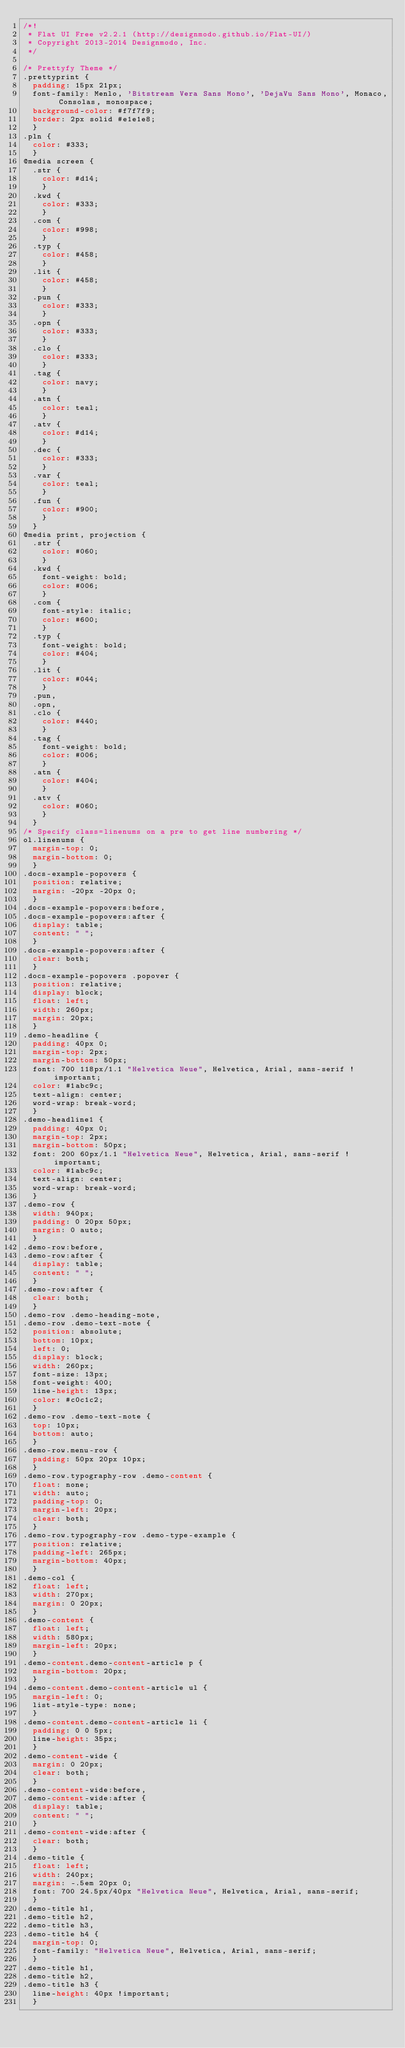Convert code to text. <code><loc_0><loc_0><loc_500><loc_500><_CSS_>/*!
 * Flat UI Free v2.2.1 (http://designmodo.github.io/Flat-UI/)
 * Copyright 2013-2014 Designmodo, Inc.
 */

/* Prettyfy Theme */
.prettyprint {
  padding: 15px 21px;
  font-family: Menlo, 'Bitstream Vera Sans Mono', 'DejaVu Sans Mono', Monaco, Consolas, monospace;
  background-color: #f7f7f9;
  border: 2px solid #e1e1e8;
  }
.pln {
  color: #333;
  }
@media screen {
  .str {
    color: #d14;
    }
  .kwd {
    color: #333;
    }
  .com {
    color: #998;
    }
  .typ {
    color: #458;
    }
  .lit {
    color: #458;
    }
  .pun {
    color: #333;
    }
  .opn {
    color: #333;
    }
  .clo {
    color: #333;
    }
  .tag {
    color: navy;
    }
  .atn {
    color: teal;
    }
  .atv {
    color: #d14;
    }
  .dec {
    color: #333;
    }
  .var {
    color: teal;
    }
  .fun {
    color: #900;
    }
  }
@media print, projection {
  .str {
    color: #060;
    }
  .kwd {
    font-weight: bold;
    color: #006;
    }
  .com {
    font-style: italic;
    color: #600;
    }
  .typ {
    font-weight: bold;
    color: #404;
    }
  .lit {
    color: #044;
    }
  .pun,
  .opn,
  .clo {
    color: #440;
    }
  .tag {
    font-weight: bold;
    color: #006;
    }
  .atn {
    color: #404;
    }
  .atv {
    color: #060;
    }
  }
/* Specify class=linenums on a pre to get line numbering */
ol.linenums {
  margin-top: 0;
  margin-bottom: 0;
  }
.docs-example-popovers {
  position: relative;
  margin: -20px -20px 0;
  }
.docs-example-popovers:before,
.docs-example-popovers:after {
  display: table;
  content: " ";
  }
.docs-example-popovers:after {
  clear: both;
  }
.docs-example-popovers .popover {
  position: relative;
  display: block;
  float: left;
  width: 260px;
  margin: 20px;
  }
.demo-headline {
  padding: 40px 0;
  margin-top: 2px;
  margin-bottom: 50px;
  font: 700 118px/1.1 "Helvetica Neue", Helvetica, Arial, sans-serif !important;
  color: #1abc9c;
  text-align: center;
  word-wrap: break-word;
  }
.demo-headline1 {
  padding: 40px 0;
  margin-top: 2px;
  margin-bottom: 50px;
  font: 200 60px/1.1 "Helvetica Neue", Helvetica, Arial, sans-serif !important;
  color: #1abc9c;
  text-align: center;
  word-wrap: break-word;
  }
.demo-row {
  width: 940px;
  padding: 0 20px 50px;
  margin: 0 auto;
  }
.demo-row:before,
.demo-row:after {
  display: table;
  content: " ";
  }
.demo-row:after {
  clear: both;
  }
.demo-row .demo-heading-note,
.demo-row .demo-text-note {
  position: absolute;
  bottom: 10px;
  left: 0;
  display: block;
  width: 260px;
  font-size: 13px;
  font-weight: 400;
  line-height: 13px;
  color: #c0c1c2;
  }
.demo-row .demo-text-note {
  top: 10px;
  bottom: auto;
  }
.demo-row.menu-row {
  padding: 50px 20px 10px;
  }
.demo-row.typography-row .demo-content {
  float: none;
  width: auto;
  padding-top: 0;
  margin-left: 20px;
  clear: both;
  }
.demo-row.typography-row .demo-type-example {
  position: relative;
  padding-left: 265px;
  margin-bottom: 40px;
  }
.demo-col {
  float: left;
  width: 270px;
  margin: 0 20px;
  }
.demo-content {
  float: left;
  width: 580px;
  margin-left: 20px;
  }
.demo-content.demo-content-article p {
  margin-bottom: 20px;
  }
.demo-content.demo-content-article ul {
  margin-left: 0;
  list-style-type: none;
  }
.demo-content.demo-content-article li {
  padding: 0 0 5px;
  line-height: 35px;
  }
.demo-content-wide {
  margin: 0 20px;
  clear: both;
  }
.demo-content-wide:before,
.demo-content-wide:after {
  display: table;
  content: " ";
  }
.demo-content-wide:after {
  clear: both;
  }
.demo-title {
  float: left;
  width: 240px;
  margin: -.5em 20px 0;
  font: 700 24.5px/40px "Helvetica Neue", Helvetica, Arial, sans-serif;
  }
.demo-title h1,
.demo-title h2,
.demo-title h3,
.demo-title h4 {
  margin-top: 0;
  font-family: "Helvetica Neue", Helvetica, Arial, sans-serif;
  }
.demo-title h1,
.demo-title h2,
.demo-title h3 {
  line-height: 40px !important;
  }</code> 